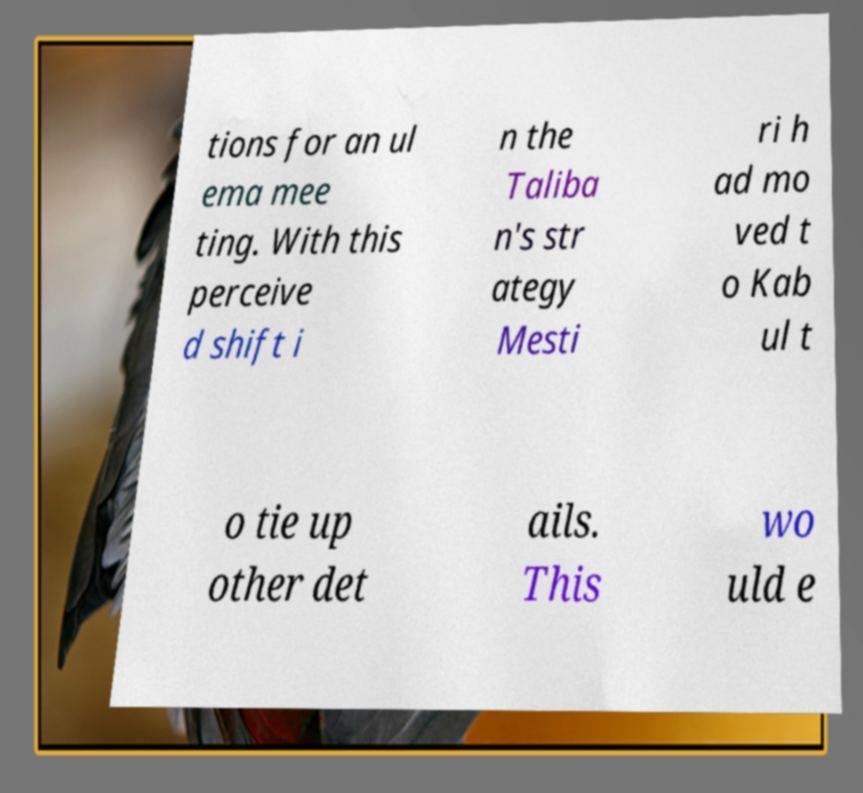Can you accurately transcribe the text from the provided image for me? tions for an ul ema mee ting. With this perceive d shift i n the Taliba n's str ategy Mesti ri h ad mo ved t o Kab ul t o tie up other det ails. This wo uld e 